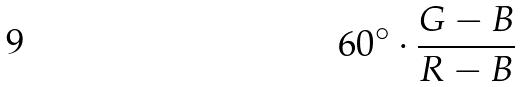Convert formula to latex. <formula><loc_0><loc_0><loc_500><loc_500>6 0 ^ { \circ } \cdot \frac { G - B } { R - B }</formula> 